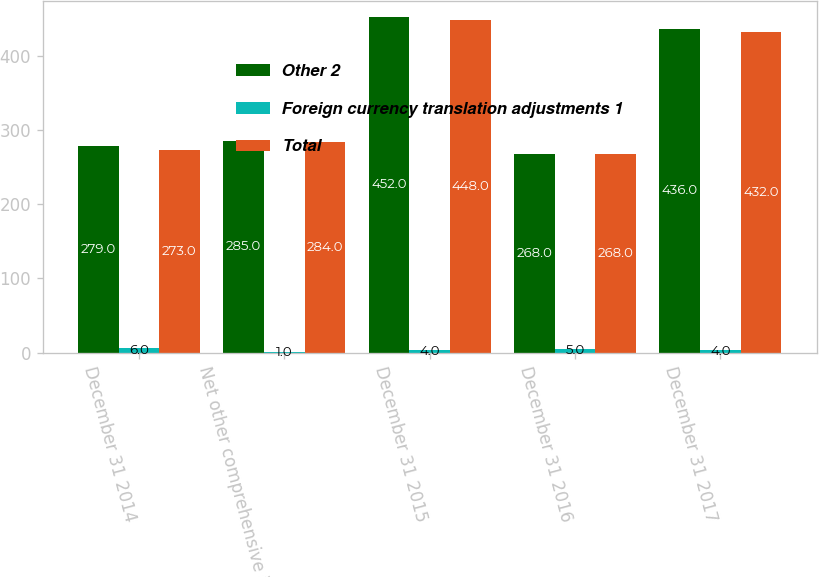<chart> <loc_0><loc_0><loc_500><loc_500><stacked_bar_chart><ecel><fcel>December 31 2014<fcel>Net other comprehensive income<fcel>December 31 2015<fcel>December 31 2016<fcel>December 31 2017<nl><fcel>Other 2<fcel>279<fcel>285<fcel>452<fcel>268<fcel>436<nl><fcel>Foreign currency translation adjustments 1<fcel>6<fcel>1<fcel>4<fcel>5<fcel>4<nl><fcel>Total<fcel>273<fcel>284<fcel>448<fcel>268<fcel>432<nl></chart> 